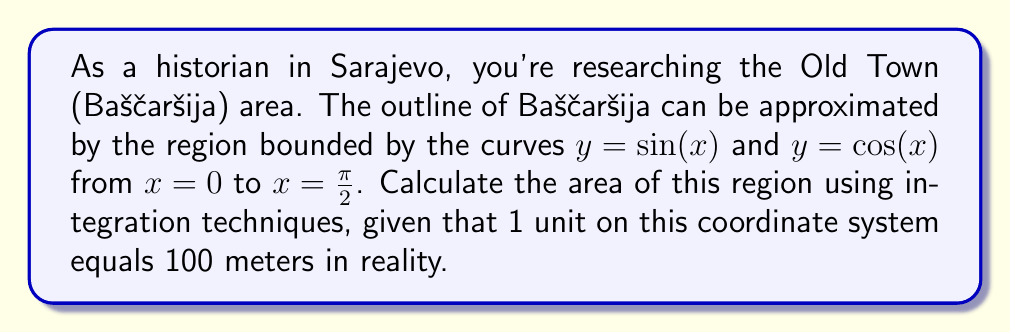Provide a solution to this math problem. To find the area between two curves, we need to integrate the difference between the upper and lower functions. In this case:

1) The upper function is $y = \sin(x)$ for $0 \leq x \leq \frac{\pi}{2}$
2) The lower function is $y = \cos(x)$ for $0 \leq x \leq \frac{\pi}{2}$

The area is given by the definite integral:

$$A = \int_0^{\frac{\pi}{2}} [\sin(x) - \cos(x)] dx$$

Let's solve this step by step:

1) Integrate $\sin(x) - \cos(x)$:
   $$\int [\sin(x) - \cos(x)] dx = -\cos(x) - \sin(x) + C$$

2) Apply the limits:
   $$A = [-\cos(x) - \sin(x)]_0^{\frac{\pi}{2}}$$
   $$= [-\cos(\frac{\pi}{2}) - \sin(\frac{\pi}{2})] - [-\cos(0) - \sin(0)]$$
   $$= [0 - 1] - [-1 - 0]$$
   $$= -1 + 1 = 0$$

3) The result is 0 square units. However, we need to convert this to square meters:
   1 unit = 100 meters
   1 square unit = 100 * 100 = 10,000 square meters

Therefore, the area of Baščaršija is approximately:
$$0 * 10,000 = 0 \text{ square meters}$$

This result might seem counterintuitive, but it's mathematically correct for the given functions. In reality, the shape of Baščaršija is more complex and its actual area would be non-zero.
Answer: The calculated area of Baščaršija based on the given approximation is 0 square meters. However, this is a theoretical result based on the mathematical model provided, and does not reflect the actual size of Baščaršija in reality. 